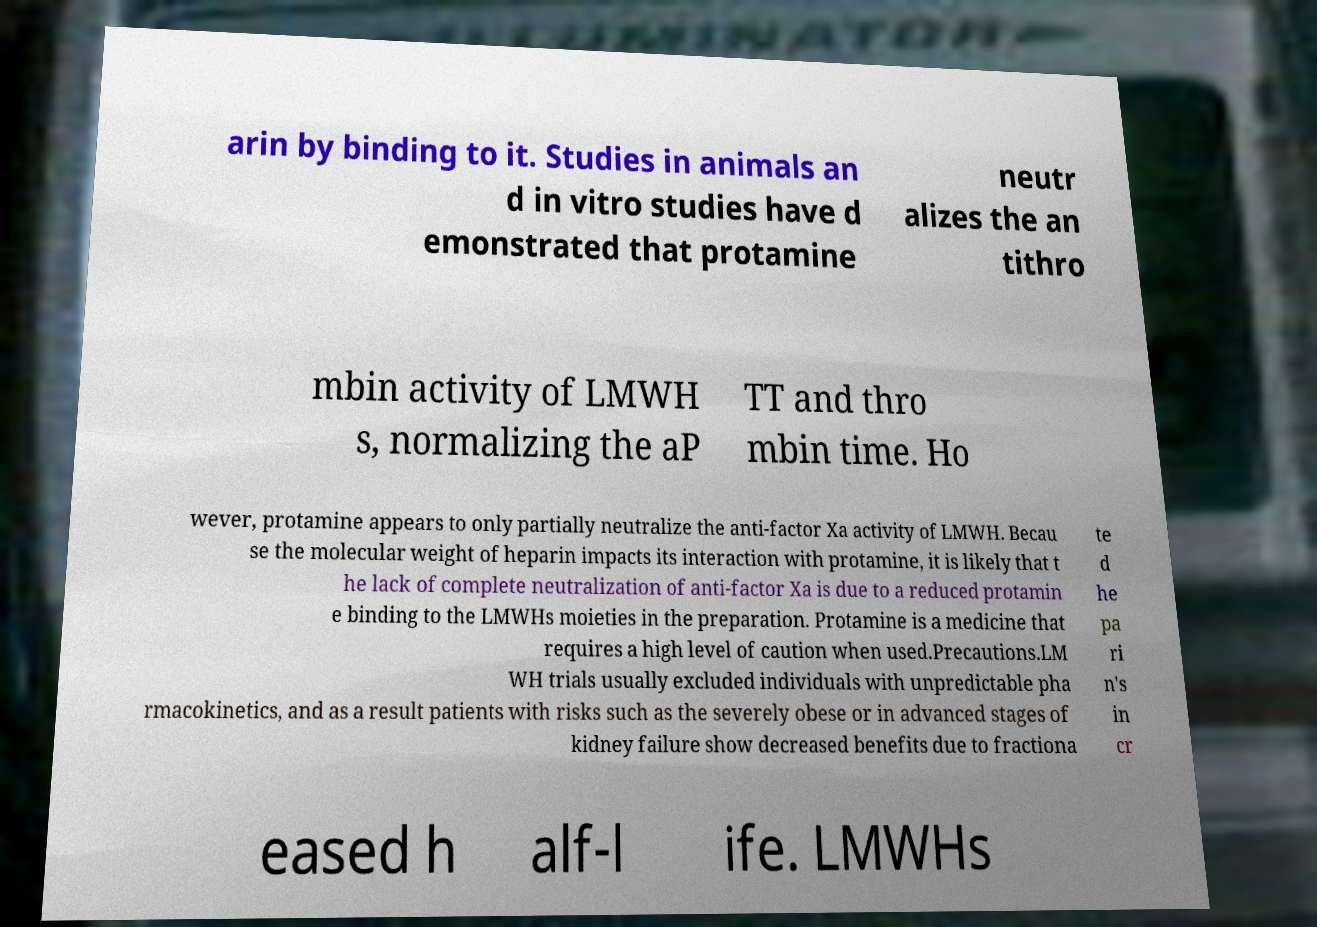What messages or text are displayed in this image? I need them in a readable, typed format. arin by binding to it. Studies in animals an d in vitro studies have d emonstrated that protamine neutr alizes the an tithro mbin activity of LMWH s, normalizing the aP TT and thro mbin time. Ho wever, protamine appears to only partially neutralize the anti-factor Xa activity of LMWH. Becau se the molecular weight of heparin impacts its interaction with protamine, it is likely that t he lack of complete neutralization of anti-factor Xa is due to a reduced protamin e binding to the LMWHs moieties in the preparation. Protamine is a medicine that requires a high level of caution when used.Precautions.LM WH trials usually excluded individuals with unpredictable pha rmacokinetics, and as a result patients with risks such as the severely obese or in advanced stages of kidney failure show decreased benefits due to fractiona te d he pa ri n's in cr eased h alf-l ife. LMWHs 